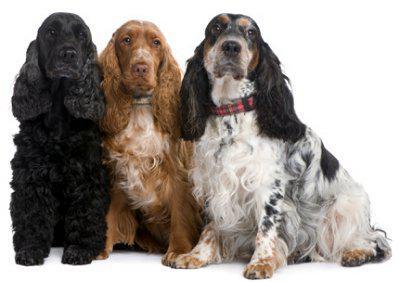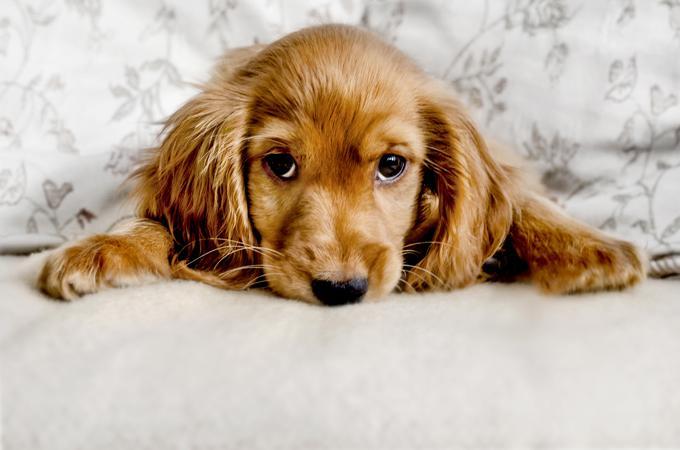The first image is the image on the left, the second image is the image on the right. For the images displayed, is the sentence "There is at least one dog against a plain white background in the image on the left." factually correct? Answer yes or no. Yes. The first image is the image on the left, the second image is the image on the right. Evaluate the accuracy of this statement regarding the images: "A dog is standing on all fours in one of the images". Is it true? Answer yes or no. No. 